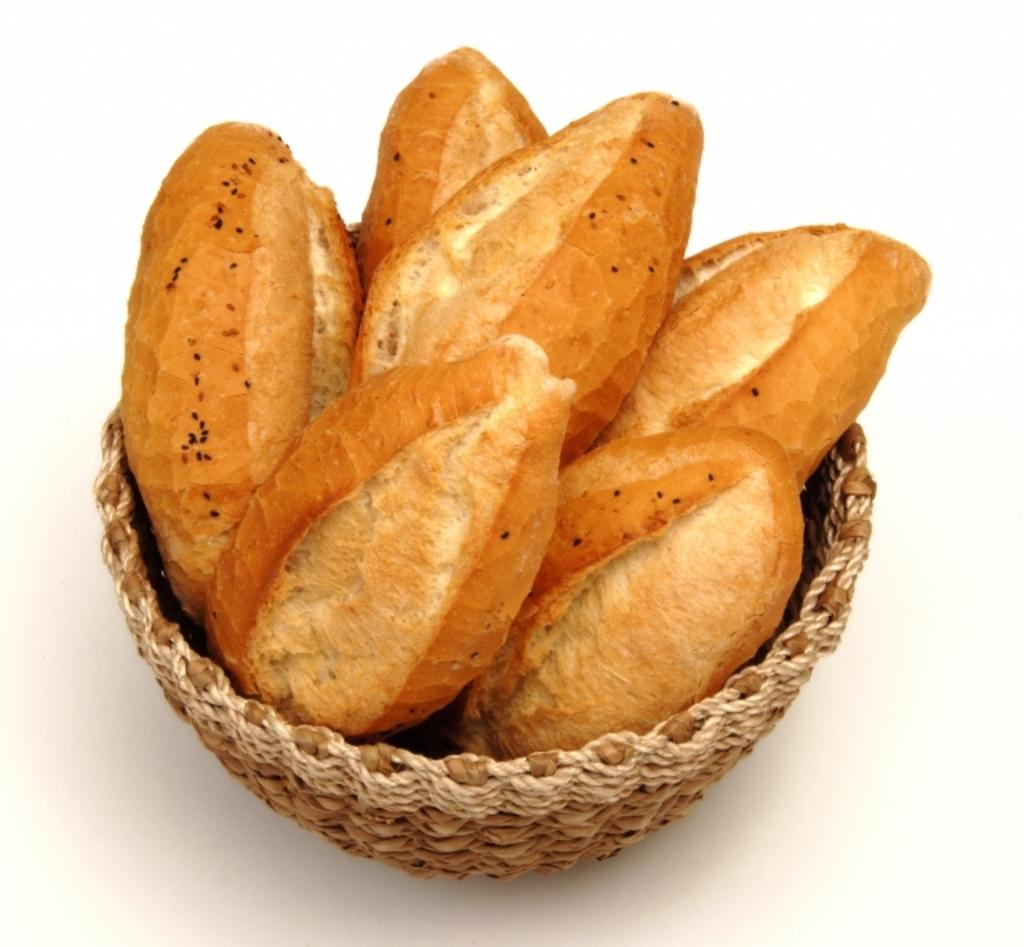What object can be seen in the image that is used for holding items? There is a basket in the image that is used for holding items. What type of food can be seen inside the basket? The basket contains a few buns. How does the father interact with the basket in the image? There is no father present in the image, so it is not possible to answer that question. 